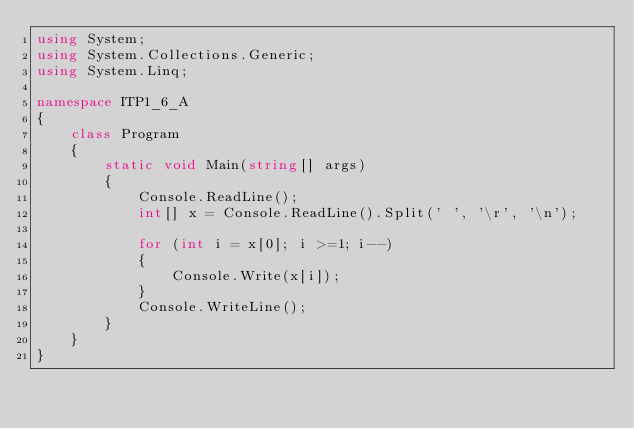Convert code to text. <code><loc_0><loc_0><loc_500><loc_500><_C#_>using System;
using System.Collections.Generic;
using System.Linq;

namespace ITP1_6_A
{
    class Program
    {
        static void Main(string[] args)
        {
            Console.ReadLine();
            int[] x = Console.ReadLine().Split(' ', '\r', '\n');
            
            for (int i = x[0]; i >=1; i--)
            {
                Console.Write(x[i]);
            }
            Console.WriteLine();
        }
    }
}
</code> 